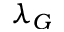<formula> <loc_0><loc_0><loc_500><loc_500>\lambda _ { G }</formula> 